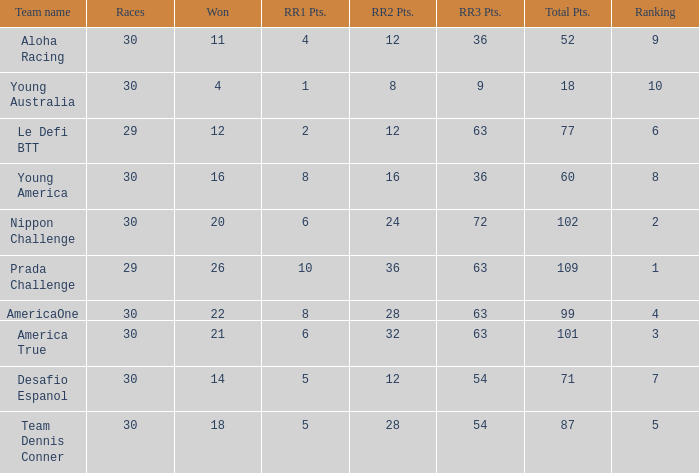Name the ranking for rr2 pts being 8 10.0. 